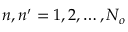Convert formula to latex. <formula><loc_0><loc_0><loc_500><loc_500>n , n ^ { \prime } = 1 , 2 , \dots , N _ { o }</formula> 